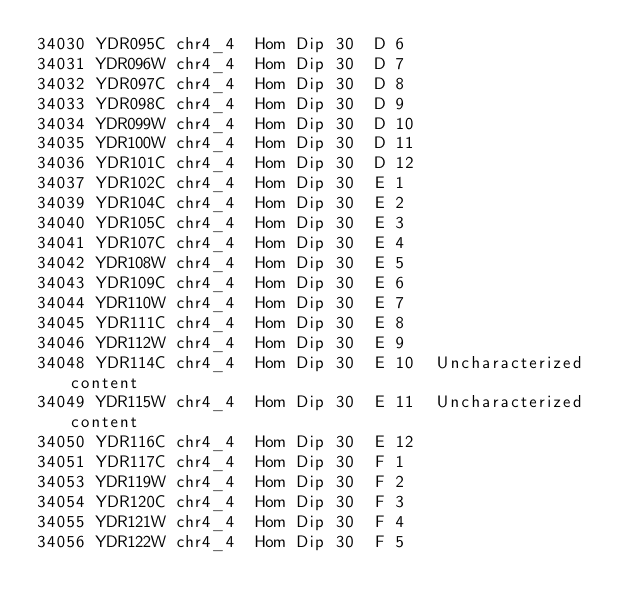Convert code to text. <code><loc_0><loc_0><loc_500><loc_500><_SQL_>34030	YDR095C	chr4_4	Hom Dip	30	D	6	
34031	YDR096W	chr4_4	Hom Dip	30	D	7	
34032	YDR097C	chr4_4	Hom Dip	30	D	8	
34033	YDR098C	chr4_4	Hom Dip	30	D	9	
34034	YDR099W	chr4_4	Hom Dip	30	D	10	
34035	YDR100W	chr4_4	Hom Dip	30	D	11	
34036	YDR101C	chr4_4	Hom Dip	30	D	12	
34037	YDR102C	chr4_4	Hom Dip	30	E	1	
34039	YDR104C	chr4_4	Hom Dip	30	E	2	
34040	YDR105C	chr4_4	Hom Dip	30	E	3	
34041	YDR107C	chr4_4	Hom Dip	30	E	4	
34042	YDR108W	chr4_4	Hom Dip	30	E	5	
34043	YDR109C	chr4_4	Hom Dip	30	E	6	
34044	YDR110W	chr4_4	Hom Dip	30	E	7	
34045	YDR111C	chr4_4	Hom Dip	30	E	8	
34046	YDR112W	chr4_4	Hom Dip	30	E	9	
34048	YDR114C	chr4_4	Hom Dip	30	E	10	Uncharacterized content
34049	YDR115W	chr4_4	Hom Dip	30	E	11	Uncharacterized content
34050	YDR116C	chr4_4	Hom Dip	30	E	12	
34051	YDR117C	chr4_4	Hom Dip	30	F	1	
34053	YDR119W	chr4_4	Hom Dip	30	F	2	
34054	YDR120C	chr4_4	Hom Dip	30	F	3	
34055	YDR121W	chr4_4	Hom Dip	30	F	4	
34056	YDR122W	chr4_4	Hom Dip	30	F	5	</code> 